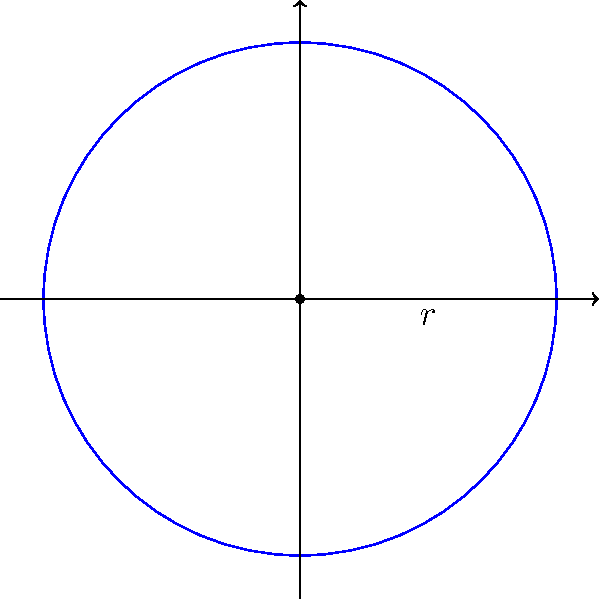As a field officer, you're advising on a center pivot irrigation system. If the system has a radius of 400 meters, what is the total area it can irrigate? (Use $\pi \approx 3.14$) To calculate the area covered by a center pivot irrigation system, we need to use the formula for the area of a circle:

1. The formula for the area of a circle is $A = \pi r^2$, where $r$ is the radius.

2. We're given that the radius is 400 meters.

3. Substituting the values:
   $A = \pi (400)^2$

4. Simplify:
   $A = \pi (160,000)$

5. Use the approximation $\pi \approx 3.14$:
   $A \approx 3.14 \times 160,000$

6. Calculate:
   $A \approx 502,400$ square meters

7. Convert to hectares (1 hectare = 10,000 square meters):
   $502,400 \div 10,000 = 50.24$ hectares

Therefore, the center pivot irrigation system can irrigate approximately 50.24 hectares.
Answer: 50.24 hectares 